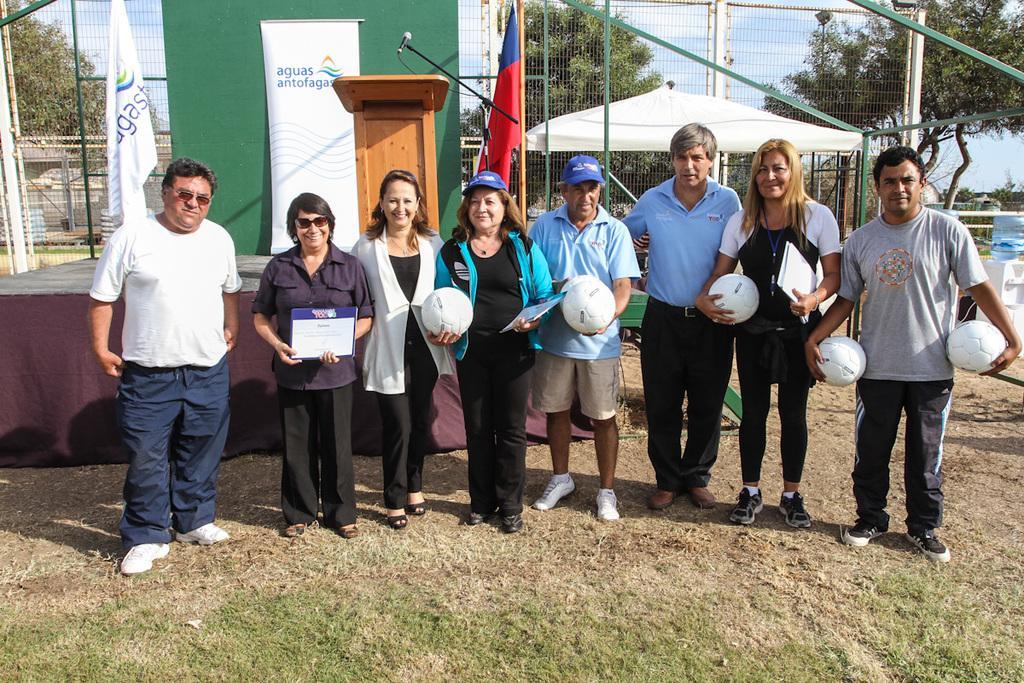Describe this image in one or two sentences. In this image we can see a group of people standing in the grass in which some of them are holding footballs and some of them are holding papers, behind them, we can see a stage, on the stage we can see the podium, a microphone attached to a small pole and a banner, there we can see two flags, fences, few poles, trees. 